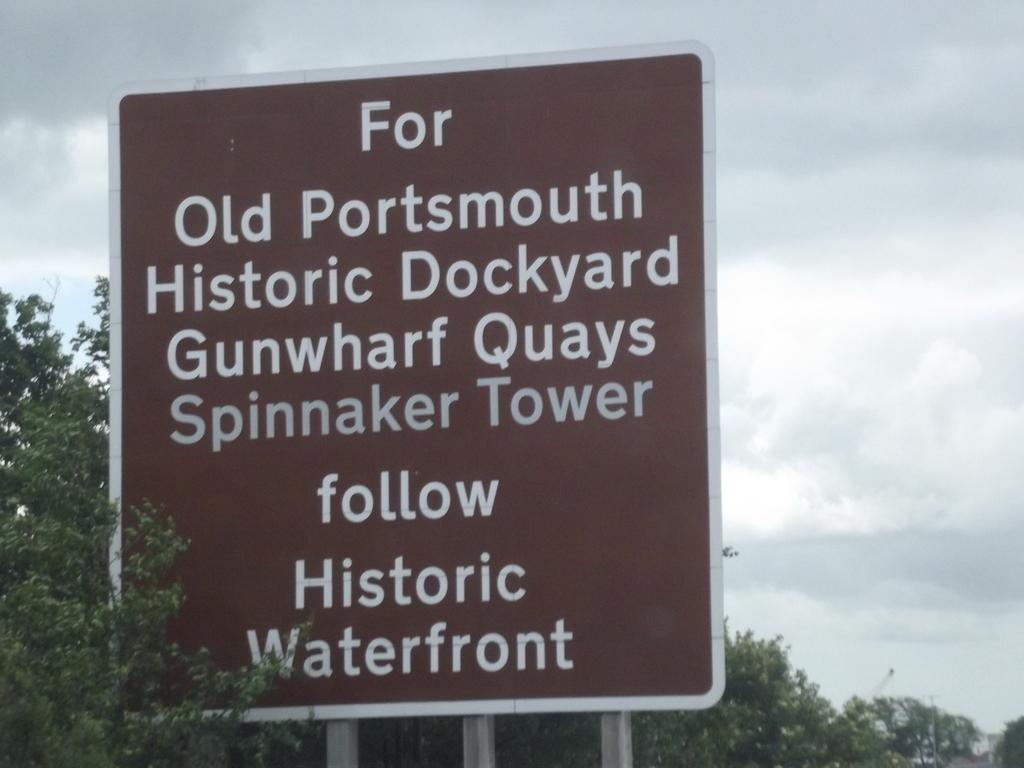What is written or displayed on the board in the image? There is text on a board in the image. What type of natural environment is visible in the image? There are many trees visible in the image. What can be seen in the background of the image? The sky is visible in the background of the image. What type of key is hanging from the tree in the image? There is no key present in the image; it only features a board with text, trees, and the sky. 